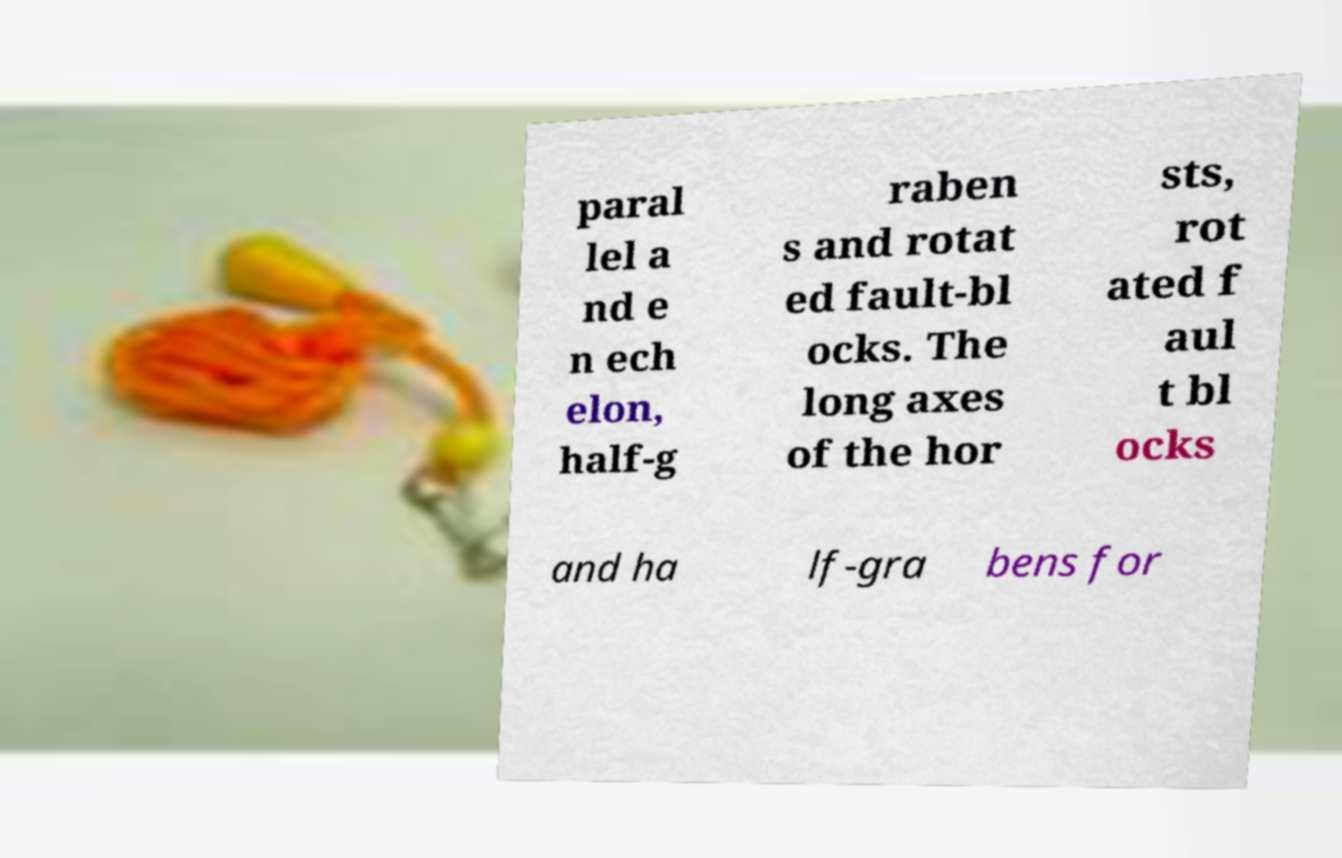Please read and relay the text visible in this image. What does it say? paral lel a nd e n ech elon, half-g raben s and rotat ed fault-bl ocks. The long axes of the hor sts, rot ated f aul t bl ocks and ha lf-gra bens for 